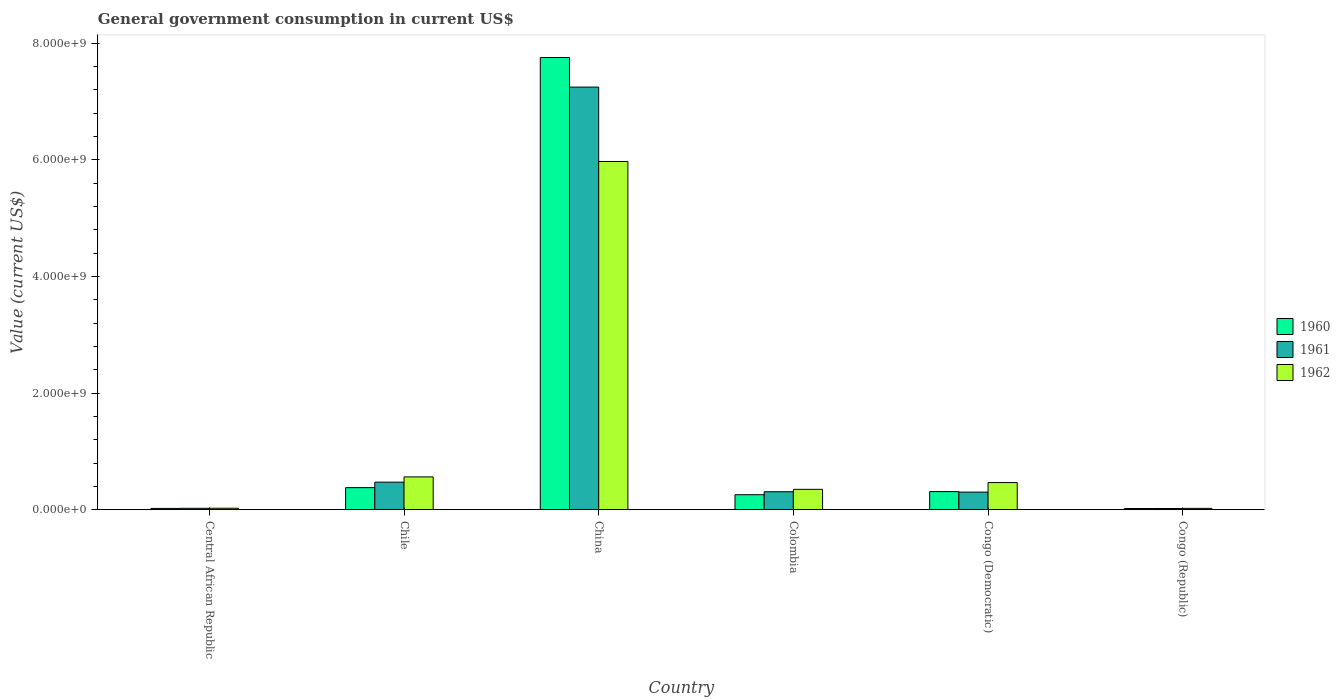How many different coloured bars are there?
Offer a terse response. 3. Are the number of bars on each tick of the X-axis equal?
Provide a short and direct response. Yes. What is the label of the 1st group of bars from the left?
Your response must be concise. Central African Republic. In how many cases, is the number of bars for a given country not equal to the number of legend labels?
Your answer should be compact. 0. What is the government conusmption in 1962 in Congo (Republic)?
Provide a succinct answer. 2.29e+07. Across all countries, what is the maximum government conusmption in 1961?
Offer a terse response. 7.25e+09. Across all countries, what is the minimum government conusmption in 1960?
Your response must be concise. 1.99e+07. In which country was the government conusmption in 1962 maximum?
Your answer should be very brief. China. In which country was the government conusmption in 1960 minimum?
Provide a succinct answer. Congo (Republic). What is the total government conusmption in 1962 in the graph?
Your answer should be very brief. 7.40e+09. What is the difference between the government conusmption in 1960 in Colombia and that in Congo (Republic)?
Your answer should be very brief. 2.37e+08. What is the difference between the government conusmption in 1962 in Congo (Republic) and the government conusmption in 1961 in Chile?
Ensure brevity in your answer.  -4.49e+08. What is the average government conusmption in 1962 per country?
Your answer should be very brief. 1.23e+09. What is the difference between the government conusmption of/in 1961 and government conusmption of/in 1962 in Central African Republic?
Ensure brevity in your answer.  -1.66e+06. What is the ratio of the government conusmption in 1961 in Congo (Democratic) to that in Congo (Republic)?
Your answer should be compact. 14.62. Is the difference between the government conusmption in 1961 in Chile and Colombia greater than the difference between the government conusmption in 1962 in Chile and Colombia?
Your answer should be very brief. No. What is the difference between the highest and the second highest government conusmption in 1962?
Your answer should be compact. 5.41e+09. What is the difference between the highest and the lowest government conusmption in 1961?
Your response must be concise. 7.23e+09. In how many countries, is the government conusmption in 1961 greater than the average government conusmption in 1961 taken over all countries?
Your answer should be very brief. 1. What does the 2nd bar from the left in Central African Republic represents?
Your response must be concise. 1961. Does the graph contain any zero values?
Offer a very short reply. No. Where does the legend appear in the graph?
Your answer should be very brief. Center right. How many legend labels are there?
Your response must be concise. 3. What is the title of the graph?
Provide a short and direct response. General government consumption in current US$. What is the label or title of the X-axis?
Give a very brief answer. Country. What is the label or title of the Y-axis?
Ensure brevity in your answer.  Value (current US$). What is the Value (current US$) of 1960 in Central African Republic?
Give a very brief answer. 2.16e+07. What is the Value (current US$) in 1961 in Central African Republic?
Your response must be concise. 2.36e+07. What is the Value (current US$) in 1962 in Central African Republic?
Make the answer very short. 2.53e+07. What is the Value (current US$) of 1960 in Chile?
Your response must be concise. 3.78e+08. What is the Value (current US$) in 1961 in Chile?
Keep it short and to the point. 4.72e+08. What is the Value (current US$) in 1962 in Chile?
Provide a succinct answer. 5.62e+08. What is the Value (current US$) of 1960 in China?
Make the answer very short. 7.75e+09. What is the Value (current US$) in 1961 in China?
Offer a very short reply. 7.25e+09. What is the Value (current US$) in 1962 in China?
Keep it short and to the point. 5.97e+09. What is the Value (current US$) in 1960 in Colombia?
Offer a very short reply. 2.57e+08. What is the Value (current US$) in 1961 in Colombia?
Your answer should be compact. 3.08e+08. What is the Value (current US$) of 1962 in Colombia?
Give a very brief answer. 3.49e+08. What is the Value (current US$) in 1960 in Congo (Democratic)?
Your answer should be compact. 3.11e+08. What is the Value (current US$) in 1961 in Congo (Democratic)?
Make the answer very short. 3.02e+08. What is the Value (current US$) in 1962 in Congo (Democratic)?
Give a very brief answer. 4.65e+08. What is the Value (current US$) of 1960 in Congo (Republic)?
Provide a succinct answer. 1.99e+07. What is the Value (current US$) of 1961 in Congo (Republic)?
Provide a short and direct response. 2.06e+07. What is the Value (current US$) in 1962 in Congo (Republic)?
Make the answer very short. 2.29e+07. Across all countries, what is the maximum Value (current US$) of 1960?
Provide a short and direct response. 7.75e+09. Across all countries, what is the maximum Value (current US$) of 1961?
Provide a succinct answer. 7.25e+09. Across all countries, what is the maximum Value (current US$) in 1962?
Provide a succinct answer. 5.97e+09. Across all countries, what is the minimum Value (current US$) in 1960?
Your response must be concise. 1.99e+07. Across all countries, what is the minimum Value (current US$) of 1961?
Keep it short and to the point. 2.06e+07. Across all countries, what is the minimum Value (current US$) of 1962?
Ensure brevity in your answer.  2.29e+07. What is the total Value (current US$) of 1960 in the graph?
Ensure brevity in your answer.  8.74e+09. What is the total Value (current US$) of 1961 in the graph?
Give a very brief answer. 8.37e+09. What is the total Value (current US$) of 1962 in the graph?
Make the answer very short. 7.40e+09. What is the difference between the Value (current US$) in 1960 in Central African Republic and that in Chile?
Provide a succinct answer. -3.56e+08. What is the difference between the Value (current US$) in 1961 in Central African Republic and that in Chile?
Your answer should be compact. -4.49e+08. What is the difference between the Value (current US$) in 1962 in Central African Republic and that in Chile?
Make the answer very short. -5.37e+08. What is the difference between the Value (current US$) in 1960 in Central African Republic and that in China?
Offer a terse response. -7.73e+09. What is the difference between the Value (current US$) of 1961 in Central African Republic and that in China?
Ensure brevity in your answer.  -7.22e+09. What is the difference between the Value (current US$) of 1962 in Central African Republic and that in China?
Offer a very short reply. -5.95e+09. What is the difference between the Value (current US$) in 1960 in Central African Republic and that in Colombia?
Ensure brevity in your answer.  -2.35e+08. What is the difference between the Value (current US$) of 1961 in Central African Republic and that in Colombia?
Make the answer very short. -2.84e+08. What is the difference between the Value (current US$) in 1962 in Central African Republic and that in Colombia?
Provide a succinct answer. -3.24e+08. What is the difference between the Value (current US$) in 1960 in Central African Republic and that in Congo (Democratic)?
Your response must be concise. -2.89e+08. What is the difference between the Value (current US$) of 1961 in Central African Republic and that in Congo (Democratic)?
Offer a very short reply. -2.78e+08. What is the difference between the Value (current US$) in 1962 in Central African Republic and that in Congo (Democratic)?
Make the answer very short. -4.40e+08. What is the difference between the Value (current US$) of 1960 in Central African Republic and that in Congo (Republic)?
Your response must be concise. 1.73e+06. What is the difference between the Value (current US$) in 1961 in Central African Republic and that in Congo (Republic)?
Offer a terse response. 3.02e+06. What is the difference between the Value (current US$) in 1962 in Central African Republic and that in Congo (Republic)?
Offer a terse response. 2.40e+06. What is the difference between the Value (current US$) of 1960 in Chile and that in China?
Give a very brief answer. -7.38e+09. What is the difference between the Value (current US$) of 1961 in Chile and that in China?
Your answer should be compact. -6.77e+09. What is the difference between the Value (current US$) in 1962 in Chile and that in China?
Your response must be concise. -5.41e+09. What is the difference between the Value (current US$) of 1960 in Chile and that in Colombia?
Your answer should be very brief. 1.21e+08. What is the difference between the Value (current US$) in 1961 in Chile and that in Colombia?
Give a very brief answer. 1.64e+08. What is the difference between the Value (current US$) in 1962 in Chile and that in Colombia?
Provide a succinct answer. 2.13e+08. What is the difference between the Value (current US$) in 1960 in Chile and that in Congo (Democratic)?
Keep it short and to the point. 6.76e+07. What is the difference between the Value (current US$) in 1961 in Chile and that in Congo (Democratic)?
Give a very brief answer. 1.71e+08. What is the difference between the Value (current US$) of 1962 in Chile and that in Congo (Democratic)?
Offer a terse response. 9.73e+07. What is the difference between the Value (current US$) in 1960 in Chile and that in Congo (Republic)?
Provide a short and direct response. 3.58e+08. What is the difference between the Value (current US$) in 1961 in Chile and that in Congo (Republic)?
Make the answer very short. 4.52e+08. What is the difference between the Value (current US$) of 1962 in Chile and that in Congo (Republic)?
Ensure brevity in your answer.  5.39e+08. What is the difference between the Value (current US$) of 1960 in China and that in Colombia?
Your response must be concise. 7.50e+09. What is the difference between the Value (current US$) in 1961 in China and that in Colombia?
Give a very brief answer. 6.94e+09. What is the difference between the Value (current US$) of 1962 in China and that in Colombia?
Keep it short and to the point. 5.62e+09. What is the difference between the Value (current US$) of 1960 in China and that in Congo (Democratic)?
Offer a very short reply. 7.44e+09. What is the difference between the Value (current US$) of 1961 in China and that in Congo (Democratic)?
Your response must be concise. 6.95e+09. What is the difference between the Value (current US$) of 1962 in China and that in Congo (Democratic)?
Provide a short and direct response. 5.51e+09. What is the difference between the Value (current US$) of 1960 in China and that in Congo (Republic)?
Offer a very short reply. 7.73e+09. What is the difference between the Value (current US$) of 1961 in China and that in Congo (Republic)?
Your response must be concise. 7.23e+09. What is the difference between the Value (current US$) in 1962 in China and that in Congo (Republic)?
Give a very brief answer. 5.95e+09. What is the difference between the Value (current US$) of 1960 in Colombia and that in Congo (Democratic)?
Your answer should be compact. -5.35e+07. What is the difference between the Value (current US$) in 1961 in Colombia and that in Congo (Democratic)?
Provide a succinct answer. 6.24e+06. What is the difference between the Value (current US$) of 1962 in Colombia and that in Congo (Democratic)?
Your answer should be compact. -1.16e+08. What is the difference between the Value (current US$) in 1960 in Colombia and that in Congo (Republic)?
Your answer should be very brief. 2.37e+08. What is the difference between the Value (current US$) in 1961 in Colombia and that in Congo (Republic)?
Keep it short and to the point. 2.87e+08. What is the difference between the Value (current US$) of 1962 in Colombia and that in Congo (Republic)?
Offer a very short reply. 3.26e+08. What is the difference between the Value (current US$) in 1960 in Congo (Democratic) and that in Congo (Republic)?
Offer a very short reply. 2.91e+08. What is the difference between the Value (current US$) of 1961 in Congo (Democratic) and that in Congo (Republic)?
Make the answer very short. 2.81e+08. What is the difference between the Value (current US$) in 1962 in Congo (Democratic) and that in Congo (Republic)?
Your answer should be very brief. 4.42e+08. What is the difference between the Value (current US$) of 1960 in Central African Republic and the Value (current US$) of 1961 in Chile?
Offer a very short reply. -4.51e+08. What is the difference between the Value (current US$) of 1960 in Central African Republic and the Value (current US$) of 1962 in Chile?
Offer a terse response. -5.41e+08. What is the difference between the Value (current US$) in 1961 in Central African Republic and the Value (current US$) in 1962 in Chile?
Your answer should be very brief. -5.39e+08. What is the difference between the Value (current US$) in 1960 in Central African Republic and the Value (current US$) in 1961 in China?
Your answer should be very brief. -7.23e+09. What is the difference between the Value (current US$) in 1960 in Central African Republic and the Value (current US$) in 1962 in China?
Ensure brevity in your answer.  -5.95e+09. What is the difference between the Value (current US$) of 1961 in Central African Republic and the Value (current US$) of 1962 in China?
Offer a very short reply. -5.95e+09. What is the difference between the Value (current US$) of 1960 in Central African Republic and the Value (current US$) of 1961 in Colombia?
Ensure brevity in your answer.  -2.86e+08. What is the difference between the Value (current US$) of 1960 in Central African Republic and the Value (current US$) of 1962 in Colombia?
Provide a short and direct response. -3.28e+08. What is the difference between the Value (current US$) of 1961 in Central African Republic and the Value (current US$) of 1962 in Colombia?
Ensure brevity in your answer.  -3.26e+08. What is the difference between the Value (current US$) in 1960 in Central African Republic and the Value (current US$) in 1961 in Congo (Democratic)?
Give a very brief answer. -2.80e+08. What is the difference between the Value (current US$) of 1960 in Central African Republic and the Value (current US$) of 1962 in Congo (Democratic)?
Make the answer very short. -4.43e+08. What is the difference between the Value (current US$) in 1961 in Central African Republic and the Value (current US$) in 1962 in Congo (Democratic)?
Your answer should be compact. -4.41e+08. What is the difference between the Value (current US$) of 1960 in Central African Republic and the Value (current US$) of 1961 in Congo (Republic)?
Your answer should be compact. 9.84e+05. What is the difference between the Value (current US$) of 1960 in Central African Republic and the Value (current US$) of 1962 in Congo (Republic)?
Provide a short and direct response. -1.29e+06. What is the difference between the Value (current US$) of 1961 in Central African Republic and the Value (current US$) of 1962 in Congo (Republic)?
Provide a short and direct response. 7.44e+05. What is the difference between the Value (current US$) of 1960 in Chile and the Value (current US$) of 1961 in China?
Your answer should be very brief. -6.87e+09. What is the difference between the Value (current US$) in 1960 in Chile and the Value (current US$) in 1962 in China?
Give a very brief answer. -5.59e+09. What is the difference between the Value (current US$) of 1961 in Chile and the Value (current US$) of 1962 in China?
Provide a succinct answer. -5.50e+09. What is the difference between the Value (current US$) of 1960 in Chile and the Value (current US$) of 1961 in Colombia?
Keep it short and to the point. 7.02e+07. What is the difference between the Value (current US$) of 1960 in Chile and the Value (current US$) of 1962 in Colombia?
Give a very brief answer. 2.89e+07. What is the difference between the Value (current US$) in 1961 in Chile and the Value (current US$) in 1962 in Colombia?
Provide a short and direct response. 1.23e+08. What is the difference between the Value (current US$) in 1960 in Chile and the Value (current US$) in 1961 in Congo (Democratic)?
Keep it short and to the point. 7.64e+07. What is the difference between the Value (current US$) in 1960 in Chile and the Value (current US$) in 1962 in Congo (Democratic)?
Your response must be concise. -8.70e+07. What is the difference between the Value (current US$) of 1961 in Chile and the Value (current US$) of 1962 in Congo (Democratic)?
Give a very brief answer. 7.10e+06. What is the difference between the Value (current US$) in 1960 in Chile and the Value (current US$) in 1961 in Congo (Republic)?
Offer a very short reply. 3.57e+08. What is the difference between the Value (current US$) of 1960 in Chile and the Value (current US$) of 1962 in Congo (Republic)?
Your answer should be compact. 3.55e+08. What is the difference between the Value (current US$) in 1961 in Chile and the Value (current US$) in 1962 in Congo (Republic)?
Keep it short and to the point. 4.49e+08. What is the difference between the Value (current US$) in 1960 in China and the Value (current US$) in 1961 in Colombia?
Give a very brief answer. 7.45e+09. What is the difference between the Value (current US$) of 1960 in China and the Value (current US$) of 1962 in Colombia?
Your answer should be compact. 7.41e+09. What is the difference between the Value (current US$) in 1961 in China and the Value (current US$) in 1962 in Colombia?
Keep it short and to the point. 6.90e+09. What is the difference between the Value (current US$) of 1960 in China and the Value (current US$) of 1961 in Congo (Democratic)?
Your answer should be compact. 7.45e+09. What is the difference between the Value (current US$) in 1960 in China and the Value (current US$) in 1962 in Congo (Democratic)?
Provide a short and direct response. 7.29e+09. What is the difference between the Value (current US$) in 1961 in China and the Value (current US$) in 1962 in Congo (Democratic)?
Ensure brevity in your answer.  6.78e+09. What is the difference between the Value (current US$) in 1960 in China and the Value (current US$) in 1961 in Congo (Republic)?
Your response must be concise. 7.73e+09. What is the difference between the Value (current US$) of 1960 in China and the Value (current US$) of 1962 in Congo (Republic)?
Keep it short and to the point. 7.73e+09. What is the difference between the Value (current US$) of 1961 in China and the Value (current US$) of 1962 in Congo (Republic)?
Your answer should be very brief. 7.22e+09. What is the difference between the Value (current US$) of 1960 in Colombia and the Value (current US$) of 1961 in Congo (Democratic)?
Your answer should be very brief. -4.46e+07. What is the difference between the Value (current US$) in 1960 in Colombia and the Value (current US$) in 1962 in Congo (Democratic)?
Ensure brevity in your answer.  -2.08e+08. What is the difference between the Value (current US$) in 1961 in Colombia and the Value (current US$) in 1962 in Congo (Democratic)?
Provide a short and direct response. -1.57e+08. What is the difference between the Value (current US$) in 1960 in Colombia and the Value (current US$) in 1961 in Congo (Republic)?
Keep it short and to the point. 2.36e+08. What is the difference between the Value (current US$) of 1960 in Colombia and the Value (current US$) of 1962 in Congo (Republic)?
Provide a short and direct response. 2.34e+08. What is the difference between the Value (current US$) of 1961 in Colombia and the Value (current US$) of 1962 in Congo (Republic)?
Your answer should be compact. 2.85e+08. What is the difference between the Value (current US$) in 1960 in Congo (Democratic) and the Value (current US$) in 1961 in Congo (Republic)?
Ensure brevity in your answer.  2.90e+08. What is the difference between the Value (current US$) of 1960 in Congo (Democratic) and the Value (current US$) of 1962 in Congo (Republic)?
Give a very brief answer. 2.88e+08. What is the difference between the Value (current US$) of 1961 in Congo (Democratic) and the Value (current US$) of 1962 in Congo (Republic)?
Provide a succinct answer. 2.79e+08. What is the average Value (current US$) in 1960 per country?
Give a very brief answer. 1.46e+09. What is the average Value (current US$) in 1961 per country?
Keep it short and to the point. 1.40e+09. What is the average Value (current US$) in 1962 per country?
Your answer should be compact. 1.23e+09. What is the difference between the Value (current US$) in 1960 and Value (current US$) in 1961 in Central African Republic?
Give a very brief answer. -2.03e+06. What is the difference between the Value (current US$) in 1960 and Value (current US$) in 1962 in Central African Republic?
Offer a terse response. -3.69e+06. What is the difference between the Value (current US$) in 1961 and Value (current US$) in 1962 in Central African Republic?
Your answer should be very brief. -1.66e+06. What is the difference between the Value (current US$) in 1960 and Value (current US$) in 1961 in Chile?
Your response must be concise. -9.41e+07. What is the difference between the Value (current US$) of 1960 and Value (current US$) of 1962 in Chile?
Ensure brevity in your answer.  -1.84e+08. What is the difference between the Value (current US$) in 1961 and Value (current US$) in 1962 in Chile?
Give a very brief answer. -9.01e+07. What is the difference between the Value (current US$) of 1960 and Value (current US$) of 1961 in China?
Your response must be concise. 5.08e+08. What is the difference between the Value (current US$) in 1960 and Value (current US$) in 1962 in China?
Provide a succinct answer. 1.78e+09. What is the difference between the Value (current US$) in 1961 and Value (current US$) in 1962 in China?
Provide a succinct answer. 1.28e+09. What is the difference between the Value (current US$) in 1960 and Value (current US$) in 1961 in Colombia?
Make the answer very short. -5.09e+07. What is the difference between the Value (current US$) of 1960 and Value (current US$) of 1962 in Colombia?
Offer a terse response. -9.22e+07. What is the difference between the Value (current US$) in 1961 and Value (current US$) in 1962 in Colombia?
Keep it short and to the point. -4.13e+07. What is the difference between the Value (current US$) of 1960 and Value (current US$) of 1961 in Congo (Democratic)?
Keep it short and to the point. 8.87e+06. What is the difference between the Value (current US$) of 1960 and Value (current US$) of 1962 in Congo (Democratic)?
Your response must be concise. -1.55e+08. What is the difference between the Value (current US$) of 1961 and Value (current US$) of 1962 in Congo (Democratic)?
Provide a succinct answer. -1.63e+08. What is the difference between the Value (current US$) of 1960 and Value (current US$) of 1961 in Congo (Republic)?
Give a very brief answer. -7.45e+05. What is the difference between the Value (current US$) in 1960 and Value (current US$) in 1962 in Congo (Republic)?
Your answer should be compact. -3.02e+06. What is the difference between the Value (current US$) in 1961 and Value (current US$) in 1962 in Congo (Republic)?
Offer a terse response. -2.27e+06. What is the ratio of the Value (current US$) of 1960 in Central African Republic to that in Chile?
Give a very brief answer. 0.06. What is the ratio of the Value (current US$) of 1961 in Central African Republic to that in Chile?
Give a very brief answer. 0.05. What is the ratio of the Value (current US$) of 1962 in Central African Republic to that in Chile?
Offer a terse response. 0.04. What is the ratio of the Value (current US$) in 1960 in Central African Republic to that in China?
Your answer should be compact. 0. What is the ratio of the Value (current US$) of 1961 in Central African Republic to that in China?
Offer a very short reply. 0. What is the ratio of the Value (current US$) of 1962 in Central African Republic to that in China?
Ensure brevity in your answer.  0. What is the ratio of the Value (current US$) of 1960 in Central African Republic to that in Colombia?
Ensure brevity in your answer.  0.08. What is the ratio of the Value (current US$) of 1961 in Central African Republic to that in Colombia?
Offer a terse response. 0.08. What is the ratio of the Value (current US$) of 1962 in Central African Republic to that in Colombia?
Offer a very short reply. 0.07. What is the ratio of the Value (current US$) in 1960 in Central African Republic to that in Congo (Democratic)?
Provide a succinct answer. 0.07. What is the ratio of the Value (current US$) of 1961 in Central African Republic to that in Congo (Democratic)?
Your answer should be very brief. 0.08. What is the ratio of the Value (current US$) in 1962 in Central African Republic to that in Congo (Democratic)?
Your answer should be very brief. 0.05. What is the ratio of the Value (current US$) in 1960 in Central African Republic to that in Congo (Republic)?
Offer a very short reply. 1.09. What is the ratio of the Value (current US$) of 1961 in Central African Republic to that in Congo (Republic)?
Make the answer very short. 1.15. What is the ratio of the Value (current US$) of 1962 in Central African Republic to that in Congo (Republic)?
Your response must be concise. 1.1. What is the ratio of the Value (current US$) in 1960 in Chile to that in China?
Keep it short and to the point. 0.05. What is the ratio of the Value (current US$) of 1961 in Chile to that in China?
Make the answer very short. 0.07. What is the ratio of the Value (current US$) in 1962 in Chile to that in China?
Offer a very short reply. 0.09. What is the ratio of the Value (current US$) in 1960 in Chile to that in Colombia?
Ensure brevity in your answer.  1.47. What is the ratio of the Value (current US$) in 1961 in Chile to that in Colombia?
Offer a terse response. 1.53. What is the ratio of the Value (current US$) of 1962 in Chile to that in Colombia?
Your response must be concise. 1.61. What is the ratio of the Value (current US$) of 1960 in Chile to that in Congo (Democratic)?
Your answer should be compact. 1.22. What is the ratio of the Value (current US$) in 1961 in Chile to that in Congo (Democratic)?
Your answer should be very brief. 1.57. What is the ratio of the Value (current US$) in 1962 in Chile to that in Congo (Democratic)?
Your answer should be compact. 1.21. What is the ratio of the Value (current US$) in 1960 in Chile to that in Congo (Republic)?
Give a very brief answer. 19.01. What is the ratio of the Value (current US$) in 1961 in Chile to that in Congo (Republic)?
Your answer should be very brief. 22.89. What is the ratio of the Value (current US$) of 1962 in Chile to that in Congo (Republic)?
Make the answer very short. 24.55. What is the ratio of the Value (current US$) of 1960 in China to that in Colombia?
Your answer should be compact. 30.17. What is the ratio of the Value (current US$) of 1961 in China to that in Colombia?
Give a very brief answer. 23.54. What is the ratio of the Value (current US$) of 1962 in China to that in Colombia?
Your answer should be compact. 17.1. What is the ratio of the Value (current US$) in 1960 in China to that in Congo (Democratic)?
Give a very brief answer. 24.97. What is the ratio of the Value (current US$) in 1961 in China to that in Congo (Democratic)?
Provide a short and direct response. 24.02. What is the ratio of the Value (current US$) of 1962 in China to that in Congo (Democratic)?
Give a very brief answer. 12.84. What is the ratio of the Value (current US$) in 1960 in China to that in Congo (Republic)?
Keep it short and to the point. 389.94. What is the ratio of the Value (current US$) in 1961 in China to that in Congo (Republic)?
Provide a short and direct response. 351.25. What is the ratio of the Value (current US$) of 1962 in China to that in Congo (Republic)?
Your answer should be very brief. 260.7. What is the ratio of the Value (current US$) in 1960 in Colombia to that in Congo (Democratic)?
Offer a very short reply. 0.83. What is the ratio of the Value (current US$) of 1961 in Colombia to that in Congo (Democratic)?
Your response must be concise. 1.02. What is the ratio of the Value (current US$) of 1962 in Colombia to that in Congo (Democratic)?
Keep it short and to the point. 0.75. What is the ratio of the Value (current US$) in 1960 in Colombia to that in Congo (Republic)?
Provide a short and direct response. 12.93. What is the ratio of the Value (current US$) of 1961 in Colombia to that in Congo (Republic)?
Give a very brief answer. 14.92. What is the ratio of the Value (current US$) in 1962 in Colombia to that in Congo (Republic)?
Offer a terse response. 15.25. What is the ratio of the Value (current US$) in 1960 in Congo (Democratic) to that in Congo (Republic)?
Your response must be concise. 15.62. What is the ratio of the Value (current US$) of 1961 in Congo (Democratic) to that in Congo (Republic)?
Make the answer very short. 14.62. What is the ratio of the Value (current US$) in 1962 in Congo (Democratic) to that in Congo (Republic)?
Give a very brief answer. 20.3. What is the difference between the highest and the second highest Value (current US$) in 1960?
Your answer should be very brief. 7.38e+09. What is the difference between the highest and the second highest Value (current US$) of 1961?
Keep it short and to the point. 6.77e+09. What is the difference between the highest and the second highest Value (current US$) of 1962?
Provide a succinct answer. 5.41e+09. What is the difference between the highest and the lowest Value (current US$) in 1960?
Ensure brevity in your answer.  7.73e+09. What is the difference between the highest and the lowest Value (current US$) of 1961?
Your answer should be very brief. 7.23e+09. What is the difference between the highest and the lowest Value (current US$) of 1962?
Make the answer very short. 5.95e+09. 